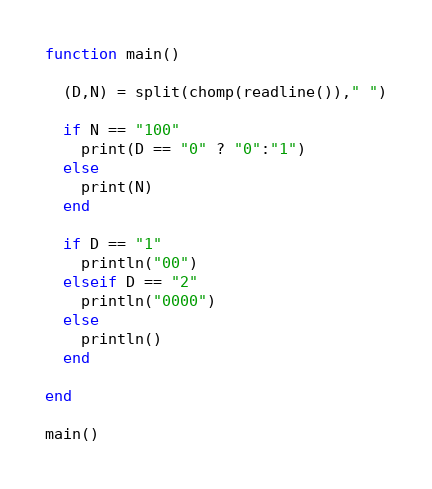<code> <loc_0><loc_0><loc_500><loc_500><_Julia_>function main()
  
  (D,N) = split(chomp(readline())," ")
  
  if N == "100"
    print(D == "0" ? "0":"1")
  else
    print(N)
  end
  
  if D == "1"
    println("00")
  elseif D == "2"
    println("0000")
  else
    println()
  end
  
end

main()</code> 